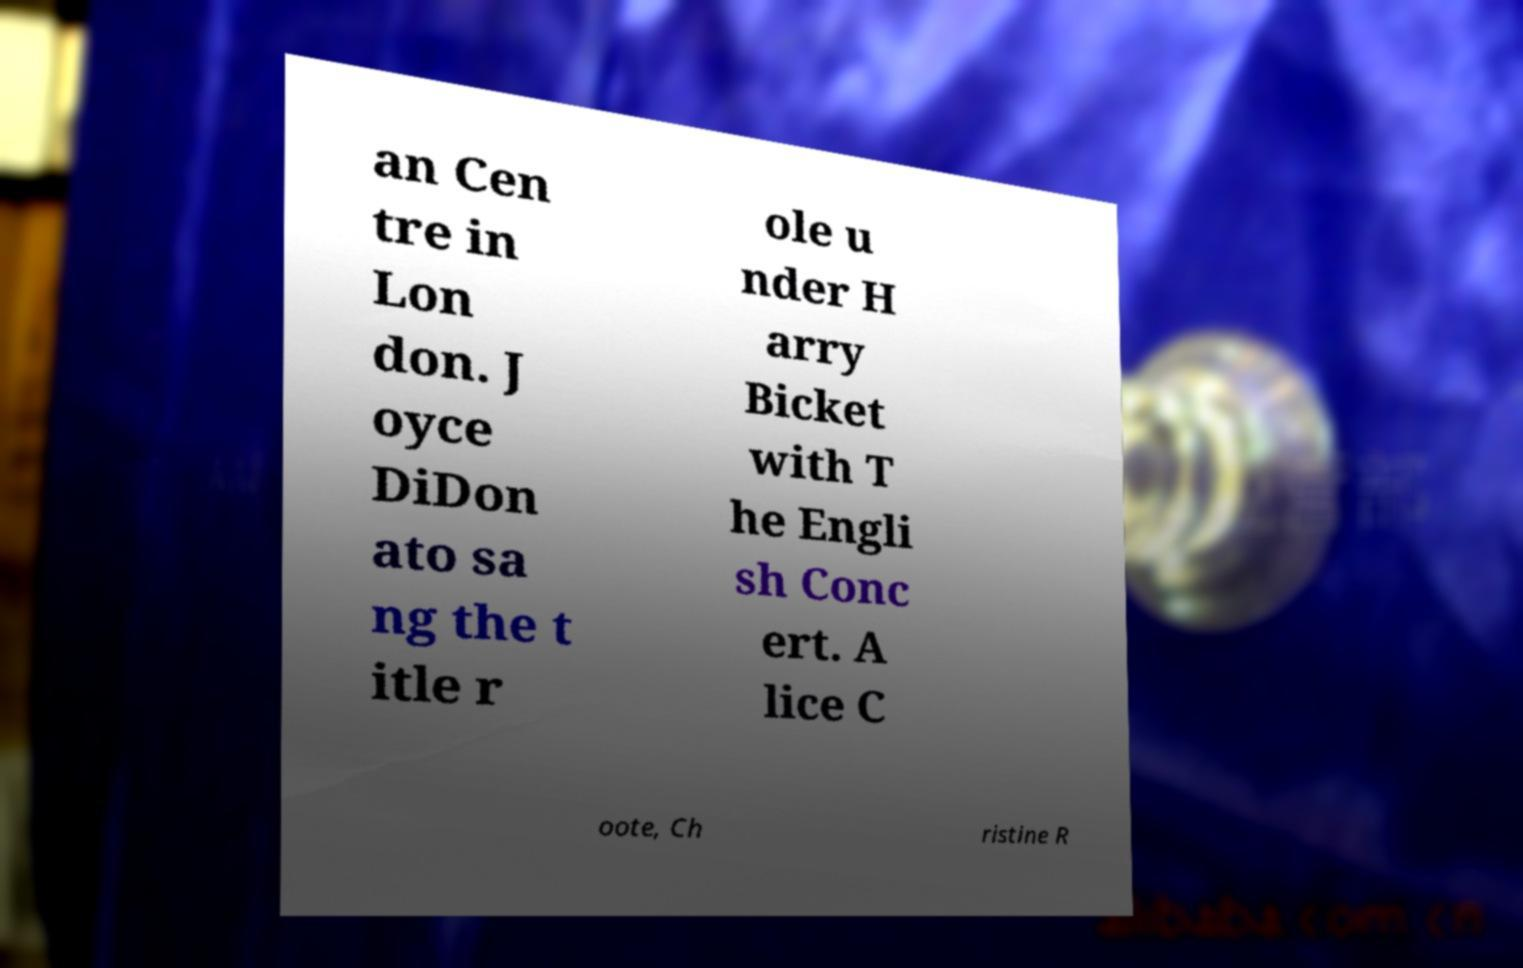There's text embedded in this image that I need extracted. Can you transcribe it verbatim? an Cen tre in Lon don. J oyce DiDon ato sa ng the t itle r ole u nder H arry Bicket with T he Engli sh Conc ert. A lice C oote, Ch ristine R 